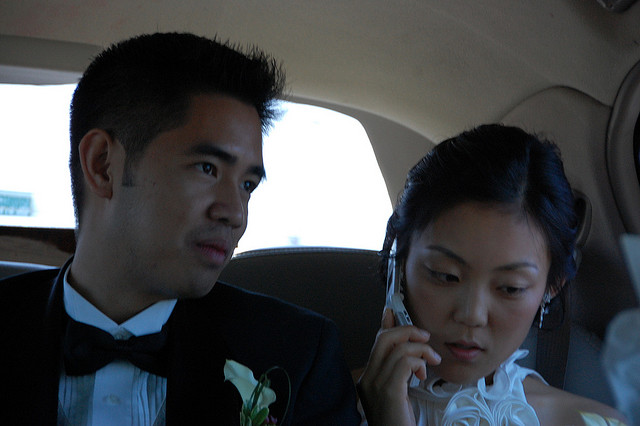<image>What emotion is the guy showing? I am not sure what emotion the guy is showing. It can be happiness, boredom, envy, or neutral. What emotion is the guy showing? I don't know what emotion the guy is showing in the image. It can be either boredom, happiness, envy, contemplative, adoration, or neutral. 